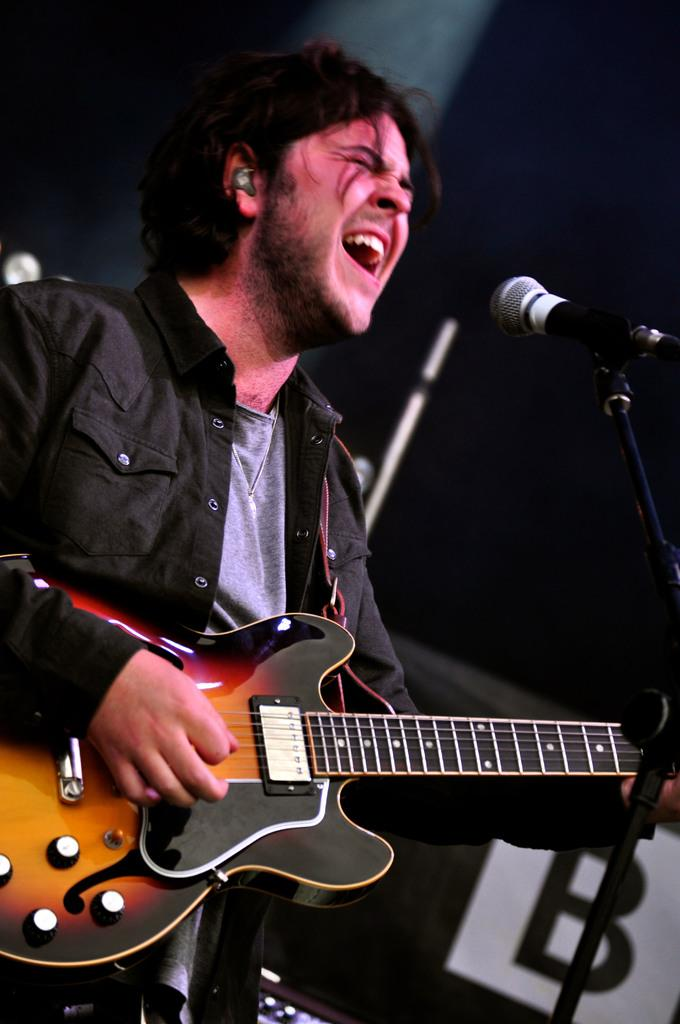What is the person in the image doing? The person is singing and playing a guitar. What is the person wearing in the image? The person is wearing a black dress. What object is the person using to amplify their voice? There is a microphone in the image. Reasoning: Let'g: Let's think step by step in order to produce the conversation. We start by identifying the main subject in the image, which is the person. Then, we describe what the person is doing, which includes singing and playing a guitar. We also mention the person's attire, specifically the black dress. Finally, we identify the object that the person is using to amplify their voice, which is the microphone. Absurd Question/Answer: Can you see a basketball court in the background of the image? There is no basketball court or any reference to basketball in the image. 